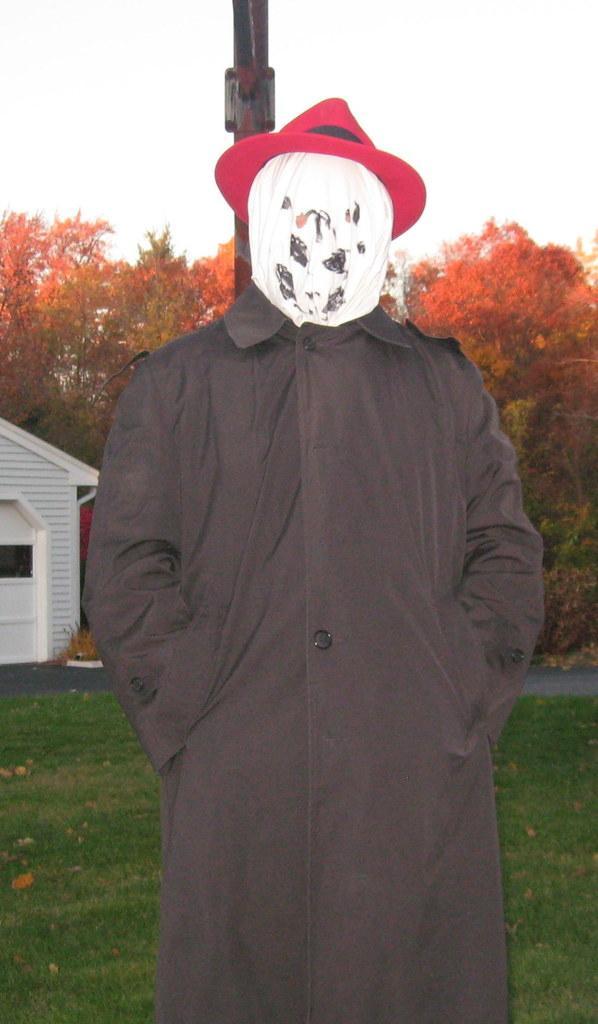In one or two sentences, can you explain what this image depicts? In this picture we can see a person wearing a hat and a mask on his face. We can see some grass and a few dry leaves on the ground. There is a path, house, trees and a pole is visible in the background. We can see the sky on top of the picture. 